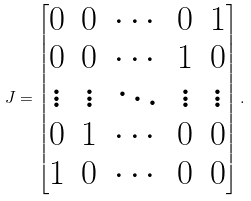<formula> <loc_0><loc_0><loc_500><loc_500>J = \begin{bmatrix} 0 & 0 & \cdots & 0 & 1 \\ 0 & 0 & \cdots & 1 & 0 \\ \vdots & \vdots & \ddots & \vdots & \vdots \\ 0 & 1 & \cdots & 0 & 0 \\ 1 & 0 & \cdots & 0 & 0 \\ \end{bmatrix} .</formula> 